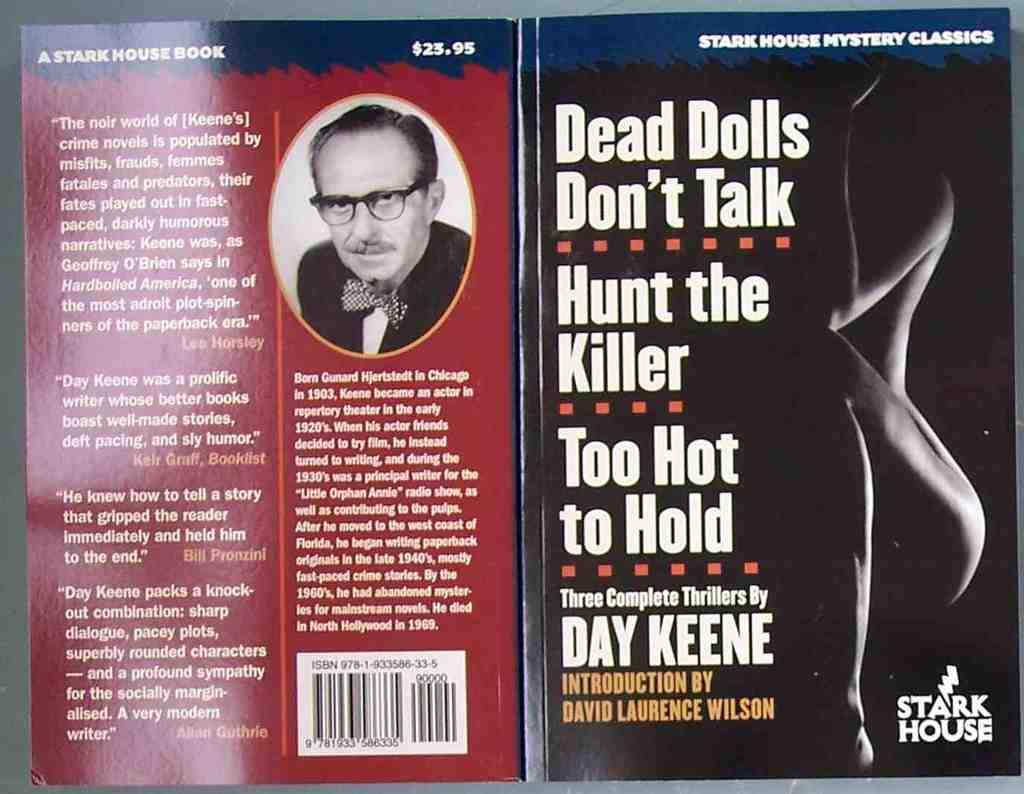Who is the author of the book?
Keep it short and to the point. Day keene. What is the title of the book?
Give a very brief answer. Dead dolls don't talk. 